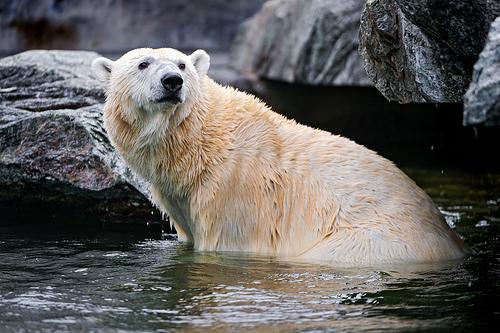Please provide a detailed comment on the state of the animal in the image. The polar bear appears to be wet and enjoying its time in the cold arctic water. What is the positioning of the bear in relation to the water and other elements in the image? The bear is in the water, with rocks behind it and a wooden log on one side. Explain the interaction between the polar bear and the water in this image. The polar bear is partially submerged in the water, indicating that it is interacting with the water by going for a swim or bath. Based on the image's content, what is the most appropriate location for the scene? The most appropriate location for this scene would be the Arctic or a cold, icy region with polar bears and cold arctic water. Mention the colors you observe for the bear and its surroundings. The polar bear is white, and it is surrounded by very cold blueish water and grey rocks. Describe the body language and the implied sentiment of the pictured animal. The polar bear appears relaxed while looking over its left shoulder, seemingly interested in something nearby. Examine the image and provide a description of any facial features of the polar bear that can be observed. The polar bear has a noticeable brown nose and a white ear. Identify the primary animal featured in the image and its activity. The main animal is a polar bear and it is in the water. From the provided image captions, what object exists behind the polar bear? There are rocks behind the polar bear. 